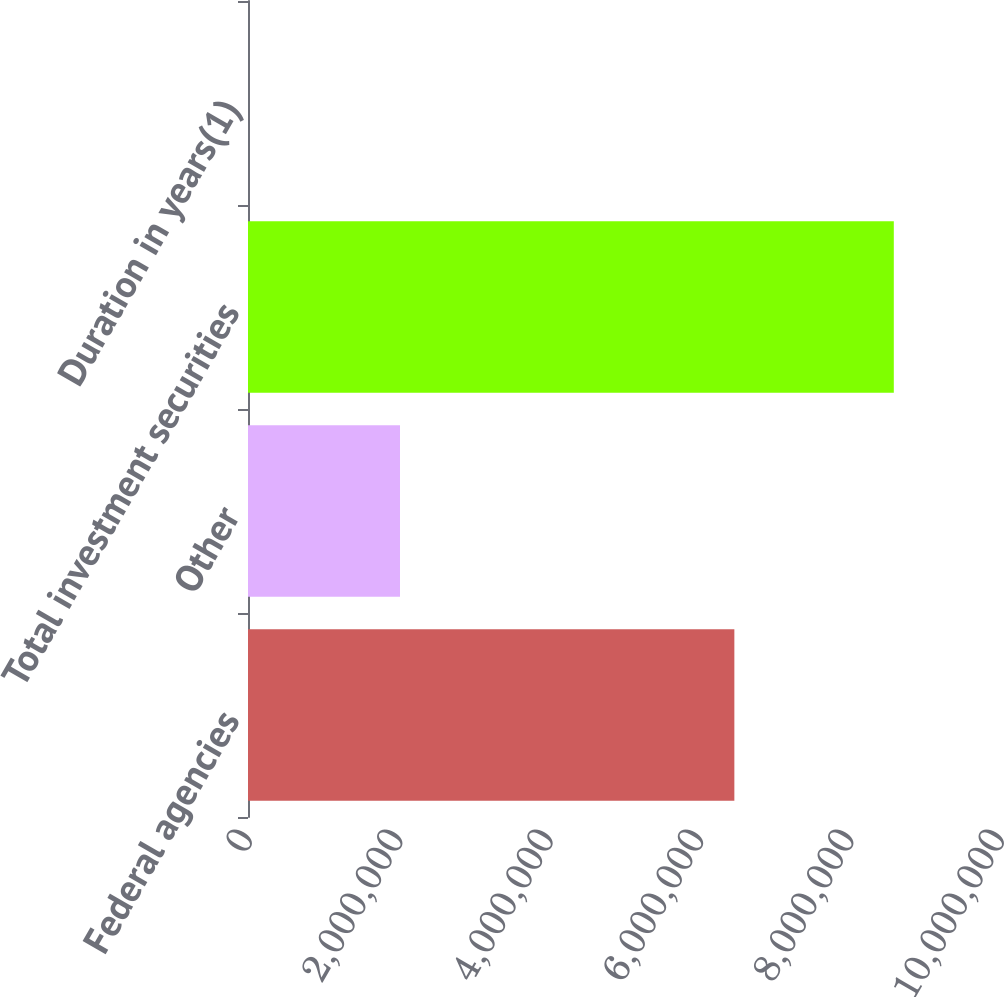Convert chart to OTSL. <chart><loc_0><loc_0><loc_500><loc_500><bar_chart><fcel>Federal agencies<fcel>Other<fcel>Total investment securities<fcel>Duration in years(1)<nl><fcel>6.4675e+06<fcel>2.02126e+06<fcel>8.58791e+06<fcel>2.4<nl></chart> 